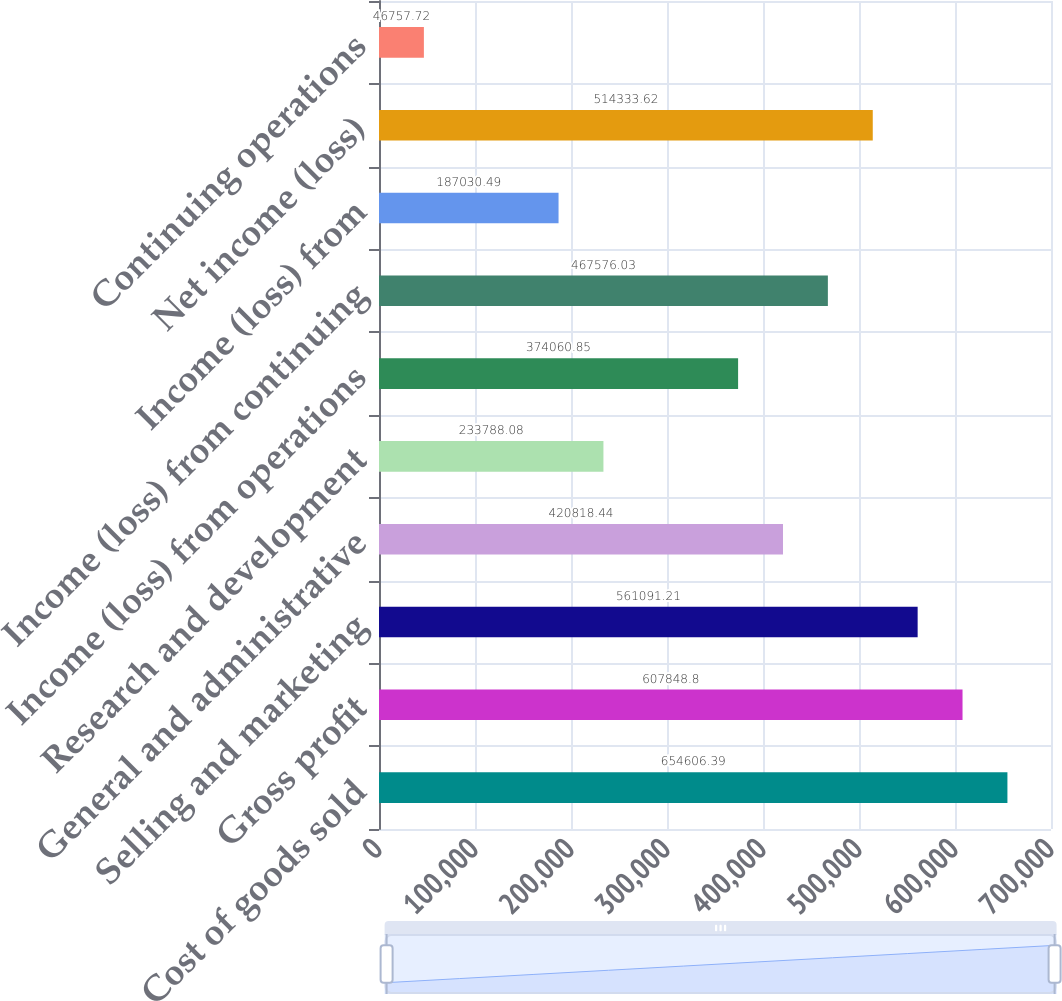Convert chart to OTSL. <chart><loc_0><loc_0><loc_500><loc_500><bar_chart><fcel>Cost of goods sold<fcel>Gross profit<fcel>Selling and marketing<fcel>General and administrative<fcel>Research and development<fcel>Income (loss) from operations<fcel>Income (loss) from continuing<fcel>Income (loss) from<fcel>Net income (loss)<fcel>Continuing operations<nl><fcel>654606<fcel>607849<fcel>561091<fcel>420818<fcel>233788<fcel>374061<fcel>467576<fcel>187030<fcel>514334<fcel>46757.7<nl></chart> 